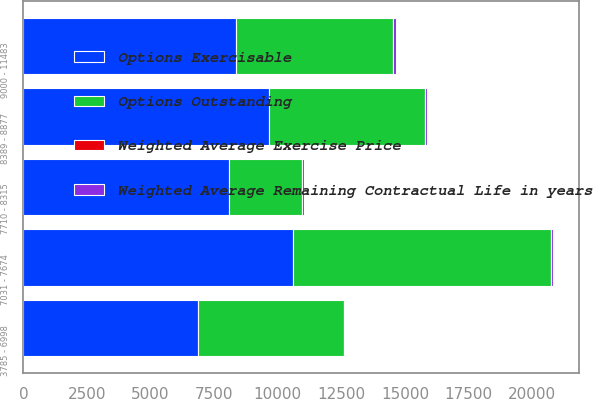Convert chart to OTSL. <chart><loc_0><loc_0><loc_500><loc_500><stacked_bar_chart><ecel><fcel>3785 - 6998<fcel>7031 - 7674<fcel>7710 - 8315<fcel>8389 - 8877<fcel>9000 - 11483<nl><fcel>Options Exercisable<fcel>6859<fcel>10579<fcel>8095<fcel>9644<fcel>8352<nl><fcel>Weighted Average Exercise Price<fcel>3<fcel>4.1<fcel>7.5<fcel>5<fcel>5.5<nl><fcel>Weighted Average Remaining Contractual Life in years<fcel>61.23<fcel>72.17<fcel>79.34<fcel>85.88<fcel>95.86<nl><fcel>Options Outstanding<fcel>5736<fcel>10144<fcel>2851<fcel>6129<fcel>6186<nl></chart> 